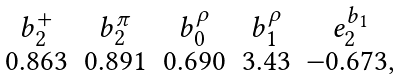Convert formula to latex. <formula><loc_0><loc_0><loc_500><loc_500>\begin{array} { c c c c c } b _ { 2 } ^ { + } & b _ { 2 } ^ { \pi } & b _ { 0 } ^ { \rho } & b _ { 1 } ^ { \rho } & e _ { 2 } ^ { b _ { 1 } } \\ 0 . 8 6 3 & 0 . 8 9 1 & 0 . 6 9 0 & 3 . 4 3 & - 0 . 6 7 3 , \end{array}</formula> 